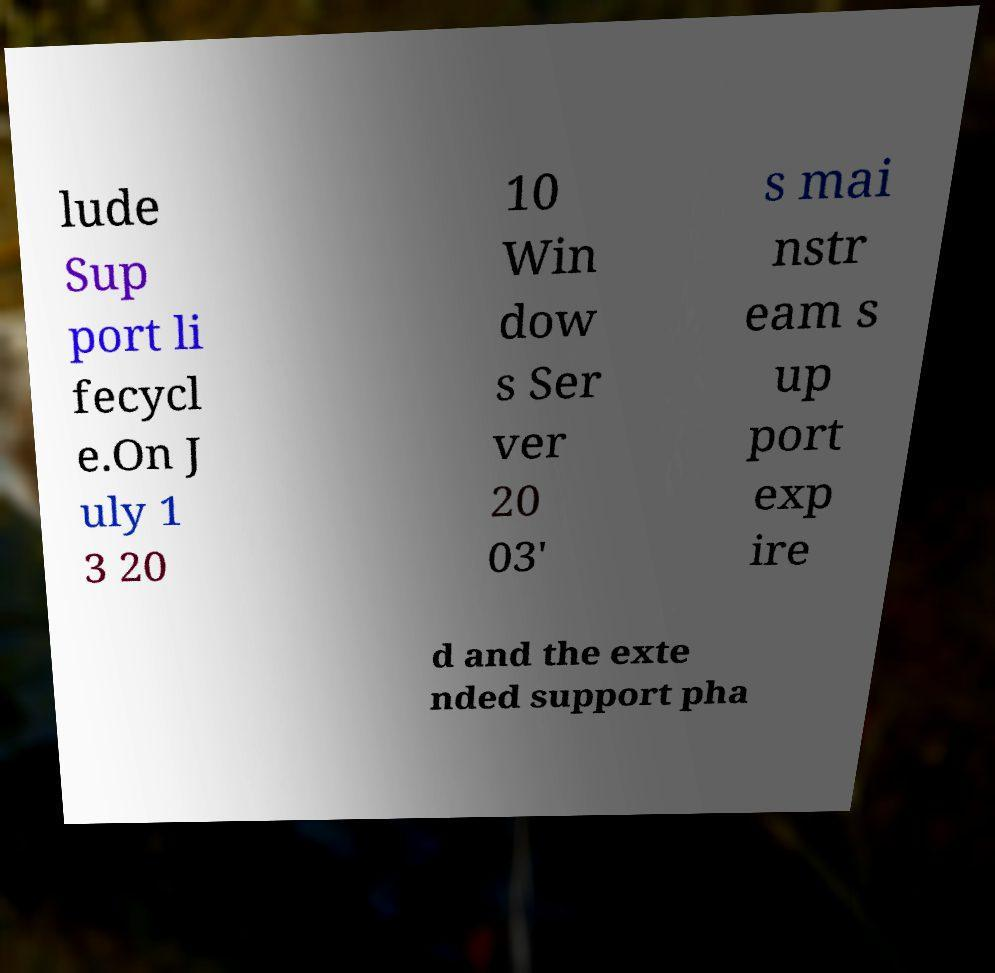Could you assist in decoding the text presented in this image and type it out clearly? lude Sup port li fecycl e.On J uly 1 3 20 10 Win dow s Ser ver 20 03' s mai nstr eam s up port exp ire d and the exte nded support pha 